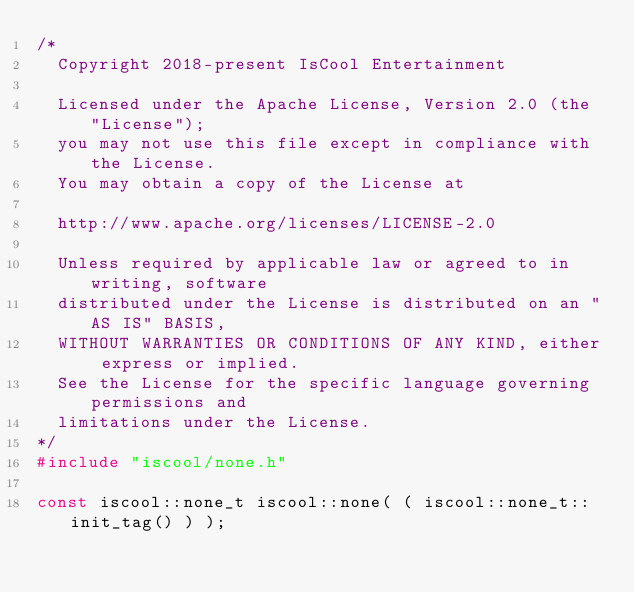<code> <loc_0><loc_0><loc_500><loc_500><_C++_>/*
  Copyright 2018-present IsCool Entertainment

  Licensed under the Apache License, Version 2.0 (the "License");
  you may not use this file except in compliance with the License.
  You may obtain a copy of the License at

  http://www.apache.org/licenses/LICENSE-2.0

  Unless required by applicable law or agreed to in writing, software
  distributed under the License is distributed on an "AS IS" BASIS,
  WITHOUT WARRANTIES OR CONDITIONS OF ANY KIND, either express or implied.
  See the License for the specific language governing permissions and
  limitations under the License.
*/
#include "iscool/none.h"

const iscool::none_t iscool::none( ( iscool::none_t::init_tag() ) );
</code> 